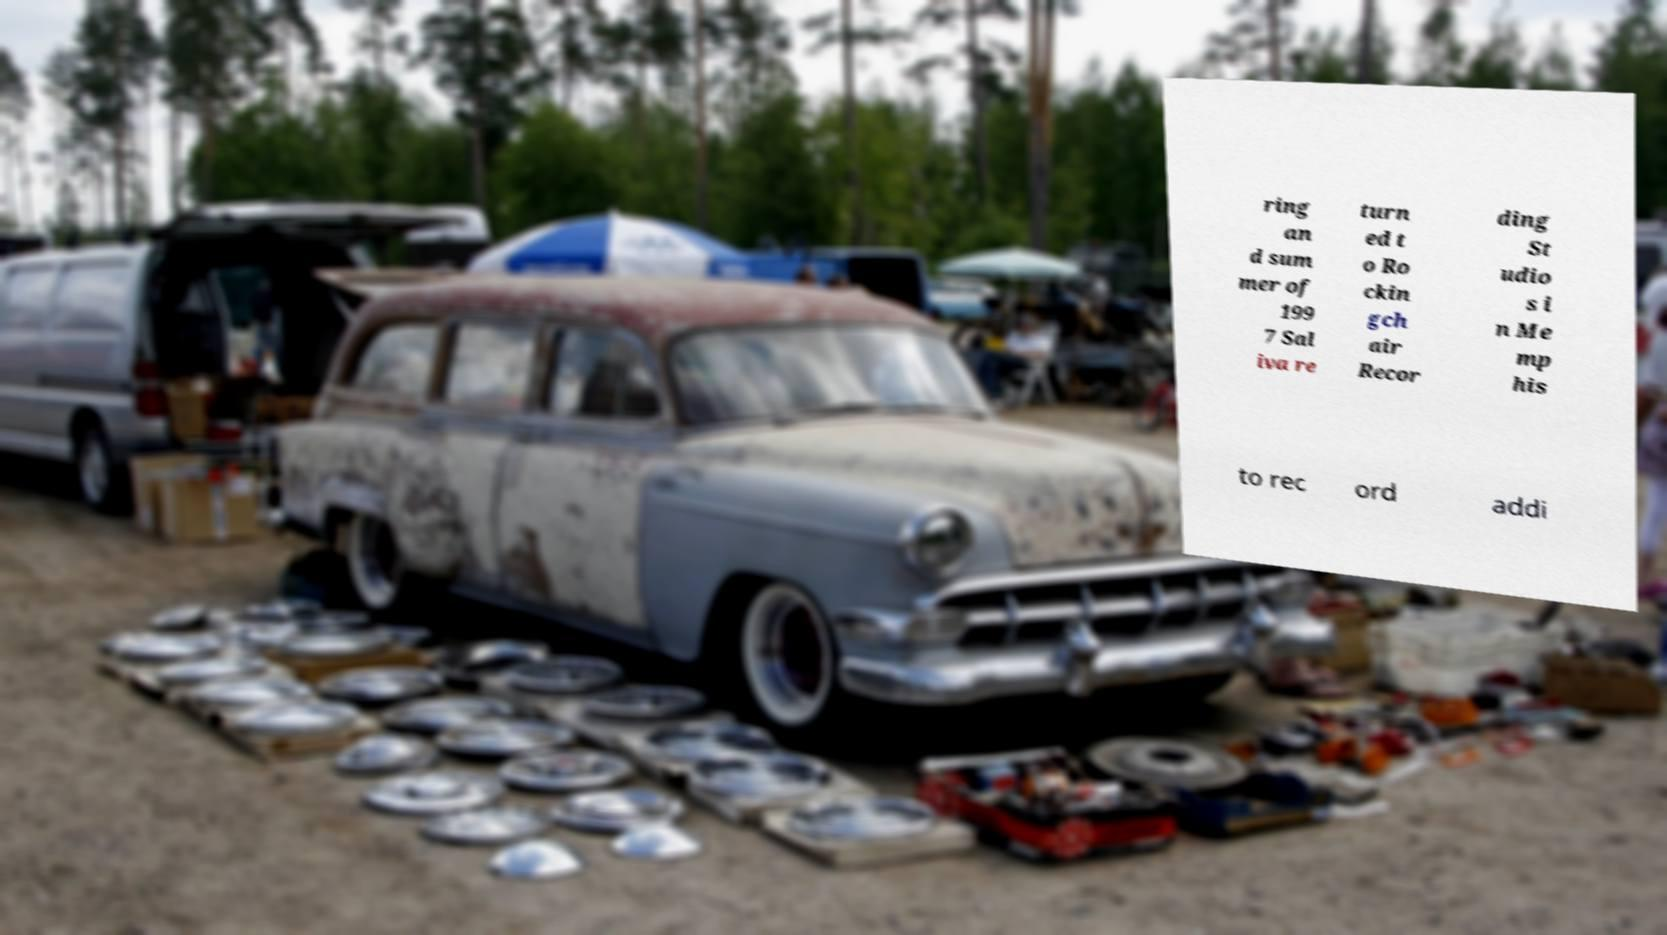Could you assist in decoding the text presented in this image and type it out clearly? ring an d sum mer of 199 7 Sal iva re turn ed t o Ro ckin gch air Recor ding St udio s i n Me mp his to rec ord addi 